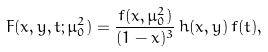<formula> <loc_0><loc_0><loc_500><loc_500>F ( x , y , t ; \mu _ { 0 } ^ { 2 } ) = \frac { f ( x , \mu _ { 0 } ^ { 2 } ) } { ( 1 - x ) ^ { 3 } } \, h ( x , y ) \, f ( t ) ,</formula> 